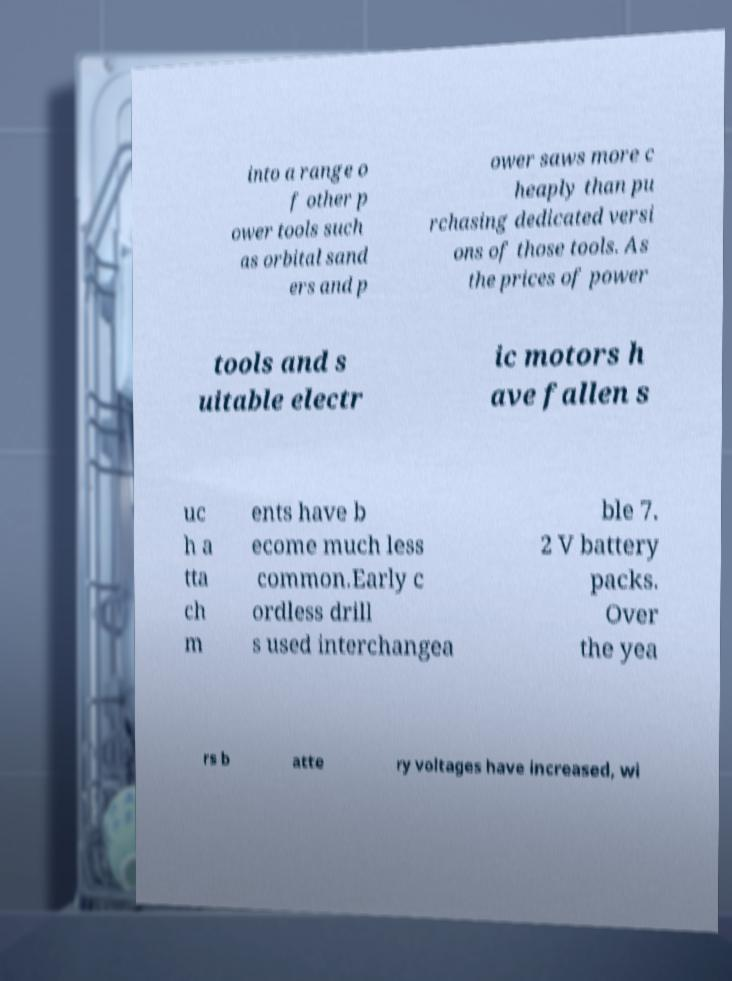I need the written content from this picture converted into text. Can you do that? into a range o f other p ower tools such as orbital sand ers and p ower saws more c heaply than pu rchasing dedicated versi ons of those tools. As the prices of power tools and s uitable electr ic motors h ave fallen s uc h a tta ch m ents have b ecome much less common.Early c ordless drill s used interchangea ble 7. 2 V battery packs. Over the yea rs b atte ry voltages have increased, wi 